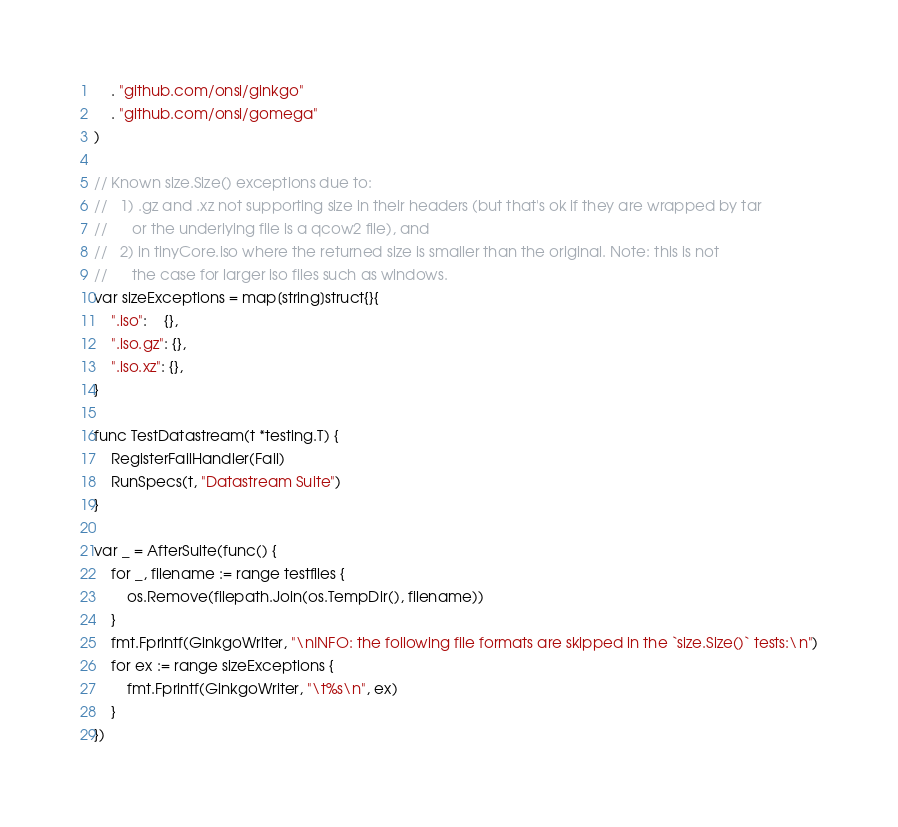Convert code to text. <code><loc_0><loc_0><loc_500><loc_500><_Go_>
	. "github.com/onsi/ginkgo"
	. "github.com/onsi/gomega"
)

// Known size.Size() exceptions due to:
//   1) .gz and .xz not supporting size in their headers (but that's ok if they are wrapped by tar
//      or the underlying file is a qcow2 file), and
//   2) in tinyCore.iso where the returned size is smaller than the original. Note: this is not
//      the case for larger iso files such as windows.
var sizeExceptions = map[string]struct{}{
	".iso":    {},
	".iso.gz": {},
	".iso.xz": {},
}

func TestDatastream(t *testing.T) {
	RegisterFailHandler(Fail)
	RunSpecs(t, "Datastream Suite")
}

var _ = AfterSuite(func() {
	for _, filename := range testfiles {
		os.Remove(filepath.Join(os.TempDir(), filename))
	}
	fmt.Fprintf(GinkgoWriter, "\nINFO: the following file formats are skipped in the `size.Size()` tests:\n")
	for ex := range sizeExceptions {
		fmt.Fprintf(GinkgoWriter, "\t%s\n", ex)
	}
})
</code> 